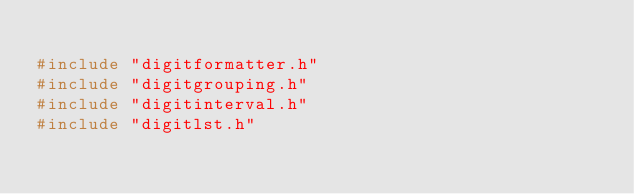<code> <loc_0><loc_0><loc_500><loc_500><_C++_>
#include "digitformatter.h"
#include "digitgrouping.h"
#include "digitinterval.h"
#include "digitlst.h"</code> 